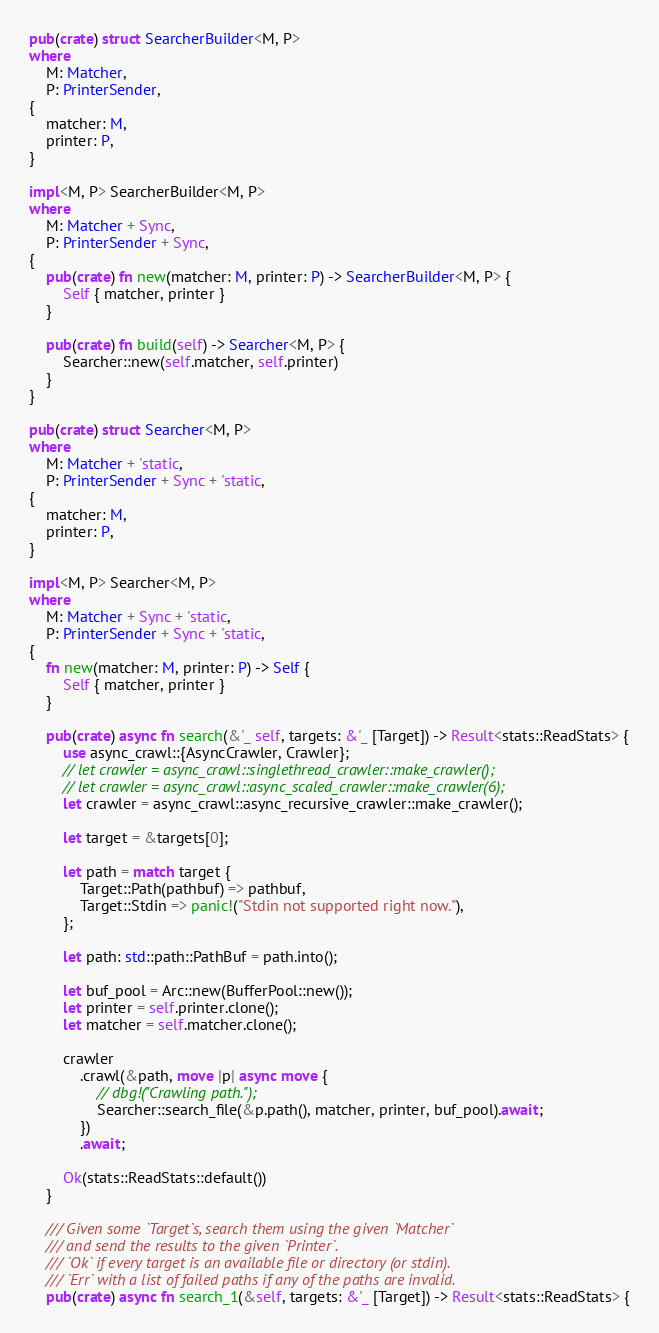<code> <loc_0><loc_0><loc_500><loc_500><_Rust_>pub(crate) struct SearcherBuilder<M, P>
where
    M: Matcher,
    P: PrinterSender,
{
    matcher: M,
    printer: P,
}

impl<M, P> SearcherBuilder<M, P>
where
    M: Matcher + Sync,
    P: PrinterSender + Sync,
{
    pub(crate) fn new(matcher: M, printer: P) -> SearcherBuilder<M, P> {
        Self { matcher, printer }
    }

    pub(crate) fn build(self) -> Searcher<M, P> {
        Searcher::new(self.matcher, self.printer)
    }
}

pub(crate) struct Searcher<M, P>
where
    M: Matcher + 'static,
    P: PrinterSender + Sync + 'static,
{
    matcher: M,
    printer: P,
}

impl<M, P> Searcher<M, P>
where
    M: Matcher + Sync + 'static,
    P: PrinterSender + Sync + 'static,
{
    fn new(matcher: M, printer: P) -> Self {
        Self { matcher, printer }
    }

    pub(crate) async fn search(&'_ self, targets: &'_ [Target]) -> Result<stats::ReadStats> {
        use async_crawl::{AsyncCrawler, Crawler};
        // let crawler = async_crawl::singlethread_crawler::make_crawler();
        // let crawler = async_crawl::async_scaled_crawler::make_crawler(6);
        let crawler = async_crawl::async_recursive_crawler::make_crawler();

        let target = &targets[0];

        let path = match target {
            Target::Path(pathbuf) => pathbuf,
            Target::Stdin => panic!("Stdin not supported right now."),
        };

        let path: std::path::PathBuf = path.into();

        let buf_pool = Arc::new(BufferPool::new());
        let printer = self.printer.clone();
        let matcher = self.matcher.clone();

        crawler
            .crawl(&path, move |p| async move {
                // dbg!("Crawling path.");
                Searcher::search_file(&p.path(), matcher, printer, buf_pool).await;
            })
            .await;

        Ok(stats::ReadStats::default())
    }

    /// Given some `Target`s, search them using the given `Matcher`
    /// and send the results to the given `Printer`.
    /// `Ok` if every target is an available file or directory (or stdin).
    /// `Err` with a list of failed paths if any of the paths are invalid.
    pub(crate) async fn search_1(&self, targets: &'_ [Target]) -> Result<stats::ReadStats> {</code> 